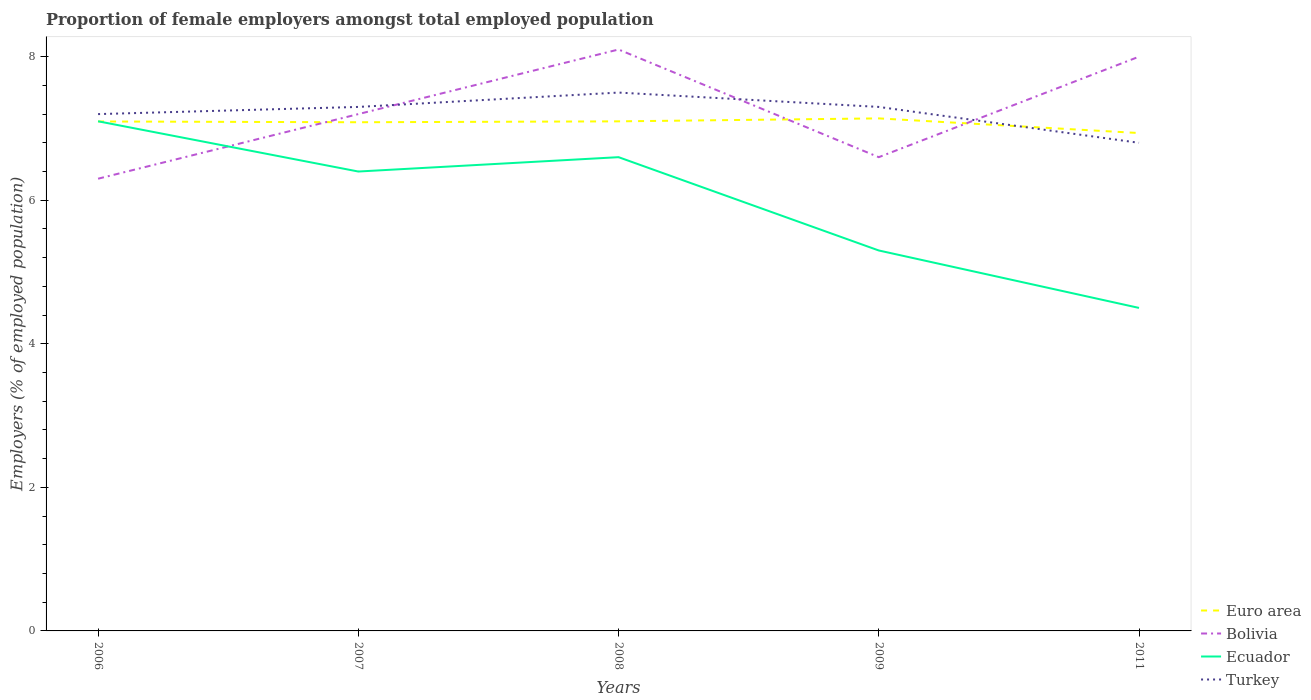How many different coloured lines are there?
Offer a terse response. 4. Is the number of lines equal to the number of legend labels?
Keep it short and to the point. Yes. Across all years, what is the maximum proportion of female employers in Bolivia?
Your answer should be very brief. 6.3. In which year was the proportion of female employers in Ecuador maximum?
Offer a very short reply. 2011. What is the total proportion of female employers in Turkey in the graph?
Make the answer very short. 0. What is the difference between the highest and the second highest proportion of female employers in Turkey?
Give a very brief answer. 0.7. How many lines are there?
Make the answer very short. 4. How many years are there in the graph?
Offer a very short reply. 5. What is the difference between two consecutive major ticks on the Y-axis?
Offer a terse response. 2. How many legend labels are there?
Your response must be concise. 4. What is the title of the graph?
Make the answer very short. Proportion of female employers amongst total employed population. What is the label or title of the Y-axis?
Provide a succinct answer. Employers (% of employed population). What is the Employers (% of employed population) of Euro area in 2006?
Your response must be concise. 7.1. What is the Employers (% of employed population) in Bolivia in 2006?
Your answer should be compact. 6.3. What is the Employers (% of employed population) of Ecuador in 2006?
Offer a very short reply. 7.1. What is the Employers (% of employed population) in Turkey in 2006?
Ensure brevity in your answer.  7.2. What is the Employers (% of employed population) in Euro area in 2007?
Give a very brief answer. 7.09. What is the Employers (% of employed population) in Bolivia in 2007?
Offer a terse response. 7.2. What is the Employers (% of employed population) of Ecuador in 2007?
Your answer should be compact. 6.4. What is the Employers (% of employed population) in Turkey in 2007?
Offer a very short reply. 7.3. What is the Employers (% of employed population) in Euro area in 2008?
Your answer should be compact. 7.1. What is the Employers (% of employed population) of Bolivia in 2008?
Your answer should be very brief. 8.1. What is the Employers (% of employed population) of Ecuador in 2008?
Make the answer very short. 6.6. What is the Employers (% of employed population) of Euro area in 2009?
Keep it short and to the point. 7.14. What is the Employers (% of employed population) of Bolivia in 2009?
Give a very brief answer. 6.6. What is the Employers (% of employed population) in Ecuador in 2009?
Your answer should be compact. 5.3. What is the Employers (% of employed population) of Turkey in 2009?
Your answer should be compact. 7.3. What is the Employers (% of employed population) of Euro area in 2011?
Offer a very short reply. 6.94. What is the Employers (% of employed population) of Bolivia in 2011?
Make the answer very short. 8. What is the Employers (% of employed population) in Turkey in 2011?
Your answer should be compact. 6.8. Across all years, what is the maximum Employers (% of employed population) of Euro area?
Offer a very short reply. 7.14. Across all years, what is the maximum Employers (% of employed population) in Bolivia?
Offer a terse response. 8.1. Across all years, what is the maximum Employers (% of employed population) in Ecuador?
Your answer should be compact. 7.1. Across all years, what is the maximum Employers (% of employed population) in Turkey?
Make the answer very short. 7.5. Across all years, what is the minimum Employers (% of employed population) of Euro area?
Keep it short and to the point. 6.94. Across all years, what is the minimum Employers (% of employed population) of Bolivia?
Provide a succinct answer. 6.3. Across all years, what is the minimum Employers (% of employed population) of Ecuador?
Provide a succinct answer. 4.5. Across all years, what is the minimum Employers (% of employed population) of Turkey?
Provide a short and direct response. 6.8. What is the total Employers (% of employed population) in Euro area in the graph?
Your response must be concise. 35.36. What is the total Employers (% of employed population) in Bolivia in the graph?
Offer a terse response. 36.2. What is the total Employers (% of employed population) of Ecuador in the graph?
Provide a succinct answer. 29.9. What is the total Employers (% of employed population) in Turkey in the graph?
Offer a terse response. 36.1. What is the difference between the Employers (% of employed population) in Euro area in 2006 and that in 2007?
Ensure brevity in your answer.  0.01. What is the difference between the Employers (% of employed population) in Bolivia in 2006 and that in 2007?
Give a very brief answer. -0.9. What is the difference between the Employers (% of employed population) in Ecuador in 2006 and that in 2007?
Provide a short and direct response. 0.7. What is the difference between the Employers (% of employed population) of Euro area in 2006 and that in 2008?
Provide a succinct answer. -0. What is the difference between the Employers (% of employed population) in Euro area in 2006 and that in 2009?
Provide a short and direct response. -0.04. What is the difference between the Employers (% of employed population) of Euro area in 2006 and that in 2011?
Keep it short and to the point. 0.16. What is the difference between the Employers (% of employed population) of Bolivia in 2006 and that in 2011?
Offer a terse response. -1.7. What is the difference between the Employers (% of employed population) of Euro area in 2007 and that in 2008?
Your answer should be compact. -0.01. What is the difference between the Employers (% of employed population) of Ecuador in 2007 and that in 2008?
Give a very brief answer. -0.2. What is the difference between the Employers (% of employed population) of Turkey in 2007 and that in 2008?
Provide a succinct answer. -0.2. What is the difference between the Employers (% of employed population) of Euro area in 2007 and that in 2009?
Make the answer very short. -0.05. What is the difference between the Employers (% of employed population) in Ecuador in 2007 and that in 2009?
Ensure brevity in your answer.  1.1. What is the difference between the Employers (% of employed population) of Euro area in 2007 and that in 2011?
Make the answer very short. 0.15. What is the difference between the Employers (% of employed population) of Bolivia in 2007 and that in 2011?
Offer a terse response. -0.8. What is the difference between the Employers (% of employed population) of Ecuador in 2007 and that in 2011?
Make the answer very short. 1.9. What is the difference between the Employers (% of employed population) in Turkey in 2007 and that in 2011?
Offer a very short reply. 0.5. What is the difference between the Employers (% of employed population) in Euro area in 2008 and that in 2009?
Provide a short and direct response. -0.04. What is the difference between the Employers (% of employed population) in Turkey in 2008 and that in 2009?
Keep it short and to the point. 0.2. What is the difference between the Employers (% of employed population) of Euro area in 2008 and that in 2011?
Make the answer very short. 0.16. What is the difference between the Employers (% of employed population) in Euro area in 2009 and that in 2011?
Offer a terse response. 0.2. What is the difference between the Employers (% of employed population) of Ecuador in 2009 and that in 2011?
Give a very brief answer. 0.8. What is the difference between the Employers (% of employed population) in Turkey in 2009 and that in 2011?
Your response must be concise. 0.5. What is the difference between the Employers (% of employed population) in Euro area in 2006 and the Employers (% of employed population) in Bolivia in 2007?
Keep it short and to the point. -0.1. What is the difference between the Employers (% of employed population) of Euro area in 2006 and the Employers (% of employed population) of Ecuador in 2007?
Offer a very short reply. 0.7. What is the difference between the Employers (% of employed population) of Euro area in 2006 and the Employers (% of employed population) of Turkey in 2007?
Make the answer very short. -0.2. What is the difference between the Employers (% of employed population) in Bolivia in 2006 and the Employers (% of employed population) in Turkey in 2007?
Keep it short and to the point. -1. What is the difference between the Employers (% of employed population) in Euro area in 2006 and the Employers (% of employed population) in Bolivia in 2008?
Your response must be concise. -1. What is the difference between the Employers (% of employed population) in Euro area in 2006 and the Employers (% of employed population) in Ecuador in 2008?
Ensure brevity in your answer.  0.5. What is the difference between the Employers (% of employed population) of Euro area in 2006 and the Employers (% of employed population) of Turkey in 2008?
Ensure brevity in your answer.  -0.4. What is the difference between the Employers (% of employed population) of Bolivia in 2006 and the Employers (% of employed population) of Ecuador in 2008?
Provide a succinct answer. -0.3. What is the difference between the Employers (% of employed population) of Euro area in 2006 and the Employers (% of employed population) of Bolivia in 2009?
Keep it short and to the point. 0.5. What is the difference between the Employers (% of employed population) in Euro area in 2006 and the Employers (% of employed population) in Ecuador in 2009?
Give a very brief answer. 1.8. What is the difference between the Employers (% of employed population) in Euro area in 2006 and the Employers (% of employed population) in Turkey in 2009?
Your answer should be compact. -0.2. What is the difference between the Employers (% of employed population) in Bolivia in 2006 and the Employers (% of employed population) in Ecuador in 2009?
Give a very brief answer. 1. What is the difference between the Employers (% of employed population) of Euro area in 2006 and the Employers (% of employed population) of Bolivia in 2011?
Your response must be concise. -0.9. What is the difference between the Employers (% of employed population) of Euro area in 2006 and the Employers (% of employed population) of Ecuador in 2011?
Offer a very short reply. 2.6. What is the difference between the Employers (% of employed population) of Euro area in 2006 and the Employers (% of employed population) of Turkey in 2011?
Provide a succinct answer. 0.3. What is the difference between the Employers (% of employed population) in Bolivia in 2006 and the Employers (% of employed population) in Ecuador in 2011?
Give a very brief answer. 1.8. What is the difference between the Employers (% of employed population) of Euro area in 2007 and the Employers (% of employed population) of Bolivia in 2008?
Ensure brevity in your answer.  -1.01. What is the difference between the Employers (% of employed population) of Euro area in 2007 and the Employers (% of employed population) of Ecuador in 2008?
Ensure brevity in your answer.  0.49. What is the difference between the Employers (% of employed population) in Euro area in 2007 and the Employers (% of employed population) in Turkey in 2008?
Ensure brevity in your answer.  -0.41. What is the difference between the Employers (% of employed population) of Ecuador in 2007 and the Employers (% of employed population) of Turkey in 2008?
Your answer should be very brief. -1.1. What is the difference between the Employers (% of employed population) in Euro area in 2007 and the Employers (% of employed population) in Bolivia in 2009?
Your answer should be very brief. 0.49. What is the difference between the Employers (% of employed population) in Euro area in 2007 and the Employers (% of employed population) in Ecuador in 2009?
Provide a succinct answer. 1.79. What is the difference between the Employers (% of employed population) of Euro area in 2007 and the Employers (% of employed population) of Turkey in 2009?
Offer a terse response. -0.21. What is the difference between the Employers (% of employed population) in Euro area in 2007 and the Employers (% of employed population) in Bolivia in 2011?
Ensure brevity in your answer.  -0.91. What is the difference between the Employers (% of employed population) of Euro area in 2007 and the Employers (% of employed population) of Ecuador in 2011?
Make the answer very short. 2.59. What is the difference between the Employers (% of employed population) in Euro area in 2007 and the Employers (% of employed population) in Turkey in 2011?
Your answer should be very brief. 0.29. What is the difference between the Employers (% of employed population) of Euro area in 2008 and the Employers (% of employed population) of Bolivia in 2009?
Provide a succinct answer. 0.5. What is the difference between the Employers (% of employed population) in Euro area in 2008 and the Employers (% of employed population) in Ecuador in 2009?
Your answer should be compact. 1.8. What is the difference between the Employers (% of employed population) in Euro area in 2008 and the Employers (% of employed population) in Turkey in 2009?
Give a very brief answer. -0.2. What is the difference between the Employers (% of employed population) in Bolivia in 2008 and the Employers (% of employed population) in Ecuador in 2009?
Offer a very short reply. 2.8. What is the difference between the Employers (% of employed population) of Euro area in 2008 and the Employers (% of employed population) of Bolivia in 2011?
Offer a terse response. -0.9. What is the difference between the Employers (% of employed population) of Euro area in 2008 and the Employers (% of employed population) of Ecuador in 2011?
Provide a short and direct response. 2.6. What is the difference between the Employers (% of employed population) of Euro area in 2008 and the Employers (% of employed population) of Turkey in 2011?
Ensure brevity in your answer.  0.3. What is the difference between the Employers (% of employed population) in Ecuador in 2008 and the Employers (% of employed population) in Turkey in 2011?
Make the answer very short. -0.2. What is the difference between the Employers (% of employed population) of Euro area in 2009 and the Employers (% of employed population) of Bolivia in 2011?
Your response must be concise. -0.86. What is the difference between the Employers (% of employed population) in Euro area in 2009 and the Employers (% of employed population) in Ecuador in 2011?
Offer a very short reply. 2.64. What is the difference between the Employers (% of employed population) of Euro area in 2009 and the Employers (% of employed population) of Turkey in 2011?
Ensure brevity in your answer.  0.34. What is the difference between the Employers (% of employed population) of Bolivia in 2009 and the Employers (% of employed population) of Turkey in 2011?
Your answer should be very brief. -0.2. What is the difference between the Employers (% of employed population) in Ecuador in 2009 and the Employers (% of employed population) in Turkey in 2011?
Make the answer very short. -1.5. What is the average Employers (% of employed population) of Euro area per year?
Provide a short and direct response. 7.07. What is the average Employers (% of employed population) in Bolivia per year?
Give a very brief answer. 7.24. What is the average Employers (% of employed population) in Ecuador per year?
Give a very brief answer. 5.98. What is the average Employers (% of employed population) in Turkey per year?
Give a very brief answer. 7.22. In the year 2006, what is the difference between the Employers (% of employed population) in Euro area and Employers (% of employed population) in Bolivia?
Ensure brevity in your answer.  0.8. In the year 2006, what is the difference between the Employers (% of employed population) of Euro area and Employers (% of employed population) of Ecuador?
Ensure brevity in your answer.  -0. In the year 2006, what is the difference between the Employers (% of employed population) of Euro area and Employers (% of employed population) of Turkey?
Keep it short and to the point. -0.1. In the year 2006, what is the difference between the Employers (% of employed population) of Bolivia and Employers (% of employed population) of Turkey?
Offer a very short reply. -0.9. In the year 2007, what is the difference between the Employers (% of employed population) in Euro area and Employers (% of employed population) in Bolivia?
Offer a very short reply. -0.11. In the year 2007, what is the difference between the Employers (% of employed population) in Euro area and Employers (% of employed population) in Ecuador?
Offer a very short reply. 0.69. In the year 2007, what is the difference between the Employers (% of employed population) in Euro area and Employers (% of employed population) in Turkey?
Offer a terse response. -0.21. In the year 2007, what is the difference between the Employers (% of employed population) in Bolivia and Employers (% of employed population) in Ecuador?
Offer a terse response. 0.8. In the year 2007, what is the difference between the Employers (% of employed population) in Bolivia and Employers (% of employed population) in Turkey?
Your response must be concise. -0.1. In the year 2007, what is the difference between the Employers (% of employed population) in Ecuador and Employers (% of employed population) in Turkey?
Offer a terse response. -0.9. In the year 2008, what is the difference between the Employers (% of employed population) in Euro area and Employers (% of employed population) in Bolivia?
Your answer should be compact. -1. In the year 2008, what is the difference between the Employers (% of employed population) of Euro area and Employers (% of employed population) of Ecuador?
Keep it short and to the point. 0.5. In the year 2008, what is the difference between the Employers (% of employed population) of Euro area and Employers (% of employed population) of Turkey?
Ensure brevity in your answer.  -0.4. In the year 2008, what is the difference between the Employers (% of employed population) of Bolivia and Employers (% of employed population) of Ecuador?
Your answer should be very brief. 1.5. In the year 2008, what is the difference between the Employers (% of employed population) of Ecuador and Employers (% of employed population) of Turkey?
Ensure brevity in your answer.  -0.9. In the year 2009, what is the difference between the Employers (% of employed population) of Euro area and Employers (% of employed population) of Bolivia?
Your answer should be very brief. 0.54. In the year 2009, what is the difference between the Employers (% of employed population) in Euro area and Employers (% of employed population) in Ecuador?
Your answer should be compact. 1.84. In the year 2009, what is the difference between the Employers (% of employed population) in Euro area and Employers (% of employed population) in Turkey?
Make the answer very short. -0.16. In the year 2009, what is the difference between the Employers (% of employed population) of Bolivia and Employers (% of employed population) of Ecuador?
Your answer should be compact. 1.3. In the year 2009, what is the difference between the Employers (% of employed population) in Bolivia and Employers (% of employed population) in Turkey?
Offer a very short reply. -0.7. In the year 2009, what is the difference between the Employers (% of employed population) of Ecuador and Employers (% of employed population) of Turkey?
Provide a short and direct response. -2. In the year 2011, what is the difference between the Employers (% of employed population) in Euro area and Employers (% of employed population) in Bolivia?
Your answer should be compact. -1.06. In the year 2011, what is the difference between the Employers (% of employed population) in Euro area and Employers (% of employed population) in Ecuador?
Give a very brief answer. 2.44. In the year 2011, what is the difference between the Employers (% of employed population) in Euro area and Employers (% of employed population) in Turkey?
Provide a short and direct response. 0.14. What is the ratio of the Employers (% of employed population) of Ecuador in 2006 to that in 2007?
Give a very brief answer. 1.11. What is the ratio of the Employers (% of employed population) of Turkey in 2006 to that in 2007?
Make the answer very short. 0.99. What is the ratio of the Employers (% of employed population) of Bolivia in 2006 to that in 2008?
Provide a succinct answer. 0.78. What is the ratio of the Employers (% of employed population) of Ecuador in 2006 to that in 2008?
Make the answer very short. 1.08. What is the ratio of the Employers (% of employed population) of Turkey in 2006 to that in 2008?
Offer a very short reply. 0.96. What is the ratio of the Employers (% of employed population) in Euro area in 2006 to that in 2009?
Offer a terse response. 0.99. What is the ratio of the Employers (% of employed population) of Bolivia in 2006 to that in 2009?
Provide a succinct answer. 0.95. What is the ratio of the Employers (% of employed population) of Ecuador in 2006 to that in 2009?
Make the answer very short. 1.34. What is the ratio of the Employers (% of employed population) of Turkey in 2006 to that in 2009?
Ensure brevity in your answer.  0.99. What is the ratio of the Employers (% of employed population) of Euro area in 2006 to that in 2011?
Give a very brief answer. 1.02. What is the ratio of the Employers (% of employed population) in Bolivia in 2006 to that in 2011?
Your answer should be very brief. 0.79. What is the ratio of the Employers (% of employed population) of Ecuador in 2006 to that in 2011?
Your answer should be very brief. 1.58. What is the ratio of the Employers (% of employed population) in Turkey in 2006 to that in 2011?
Your response must be concise. 1.06. What is the ratio of the Employers (% of employed population) in Euro area in 2007 to that in 2008?
Provide a short and direct response. 1. What is the ratio of the Employers (% of employed population) in Bolivia in 2007 to that in 2008?
Give a very brief answer. 0.89. What is the ratio of the Employers (% of employed population) of Ecuador in 2007 to that in 2008?
Your answer should be compact. 0.97. What is the ratio of the Employers (% of employed population) of Turkey in 2007 to that in 2008?
Ensure brevity in your answer.  0.97. What is the ratio of the Employers (% of employed population) of Ecuador in 2007 to that in 2009?
Your answer should be very brief. 1.21. What is the ratio of the Employers (% of employed population) of Turkey in 2007 to that in 2009?
Your response must be concise. 1. What is the ratio of the Employers (% of employed population) of Euro area in 2007 to that in 2011?
Offer a terse response. 1.02. What is the ratio of the Employers (% of employed population) in Ecuador in 2007 to that in 2011?
Provide a short and direct response. 1.42. What is the ratio of the Employers (% of employed population) of Turkey in 2007 to that in 2011?
Your response must be concise. 1.07. What is the ratio of the Employers (% of employed population) in Euro area in 2008 to that in 2009?
Provide a succinct answer. 0.99. What is the ratio of the Employers (% of employed population) of Bolivia in 2008 to that in 2009?
Your answer should be very brief. 1.23. What is the ratio of the Employers (% of employed population) in Ecuador in 2008 to that in 2009?
Offer a terse response. 1.25. What is the ratio of the Employers (% of employed population) of Turkey in 2008 to that in 2009?
Provide a short and direct response. 1.03. What is the ratio of the Employers (% of employed population) in Euro area in 2008 to that in 2011?
Make the answer very short. 1.02. What is the ratio of the Employers (% of employed population) of Bolivia in 2008 to that in 2011?
Your answer should be very brief. 1.01. What is the ratio of the Employers (% of employed population) of Ecuador in 2008 to that in 2011?
Your response must be concise. 1.47. What is the ratio of the Employers (% of employed population) in Turkey in 2008 to that in 2011?
Your response must be concise. 1.1. What is the ratio of the Employers (% of employed population) of Euro area in 2009 to that in 2011?
Keep it short and to the point. 1.03. What is the ratio of the Employers (% of employed population) of Bolivia in 2009 to that in 2011?
Ensure brevity in your answer.  0.82. What is the ratio of the Employers (% of employed population) of Ecuador in 2009 to that in 2011?
Offer a very short reply. 1.18. What is the ratio of the Employers (% of employed population) of Turkey in 2009 to that in 2011?
Ensure brevity in your answer.  1.07. What is the difference between the highest and the second highest Employers (% of employed population) in Euro area?
Your answer should be very brief. 0.04. What is the difference between the highest and the lowest Employers (% of employed population) of Euro area?
Ensure brevity in your answer.  0.2. What is the difference between the highest and the lowest Employers (% of employed population) in Bolivia?
Your answer should be compact. 1.8. What is the difference between the highest and the lowest Employers (% of employed population) in Ecuador?
Ensure brevity in your answer.  2.6. What is the difference between the highest and the lowest Employers (% of employed population) of Turkey?
Your answer should be compact. 0.7. 